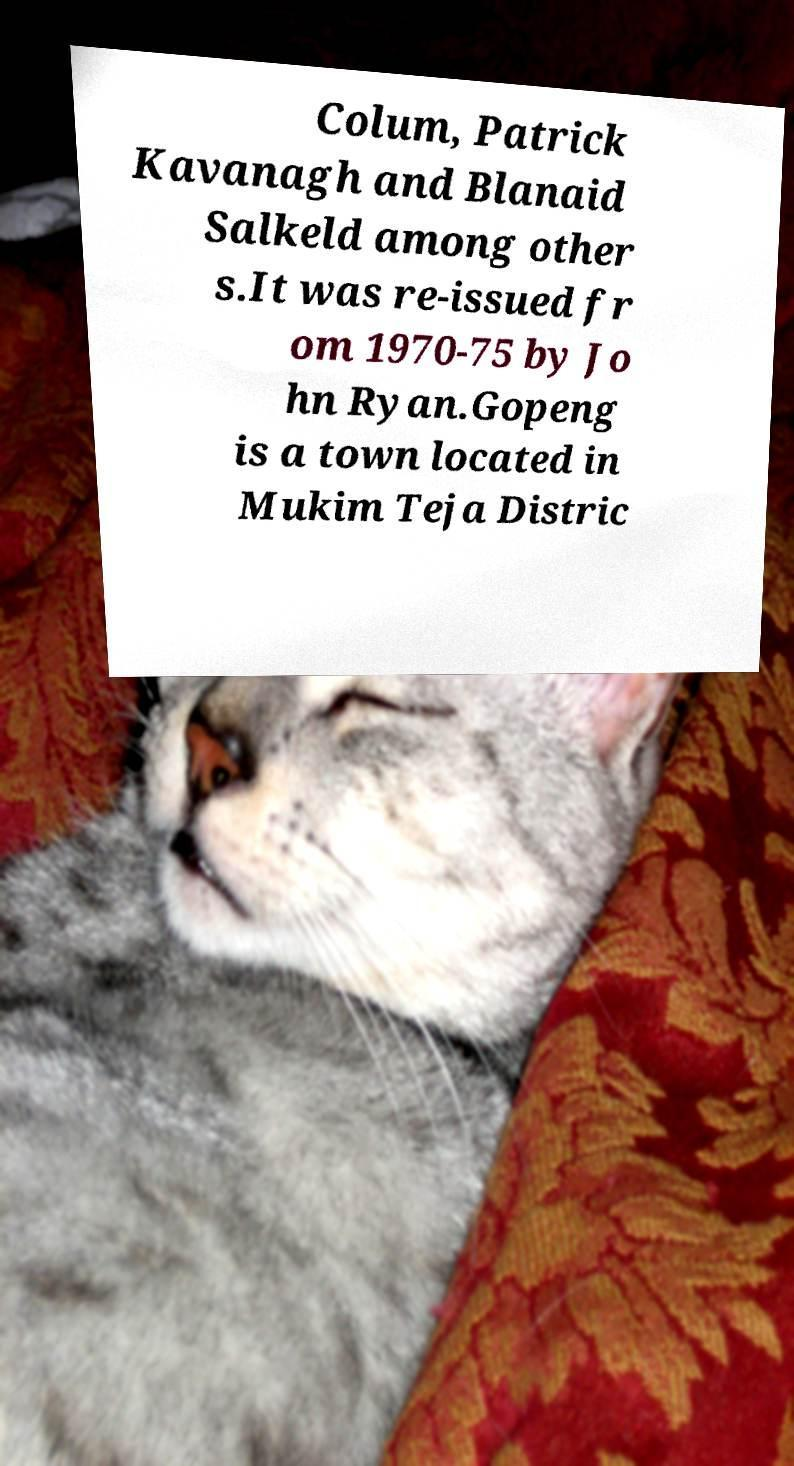For documentation purposes, I need the text within this image transcribed. Could you provide that? Colum, Patrick Kavanagh and Blanaid Salkeld among other s.It was re-issued fr om 1970-75 by Jo hn Ryan.Gopeng is a town located in Mukim Teja Distric 